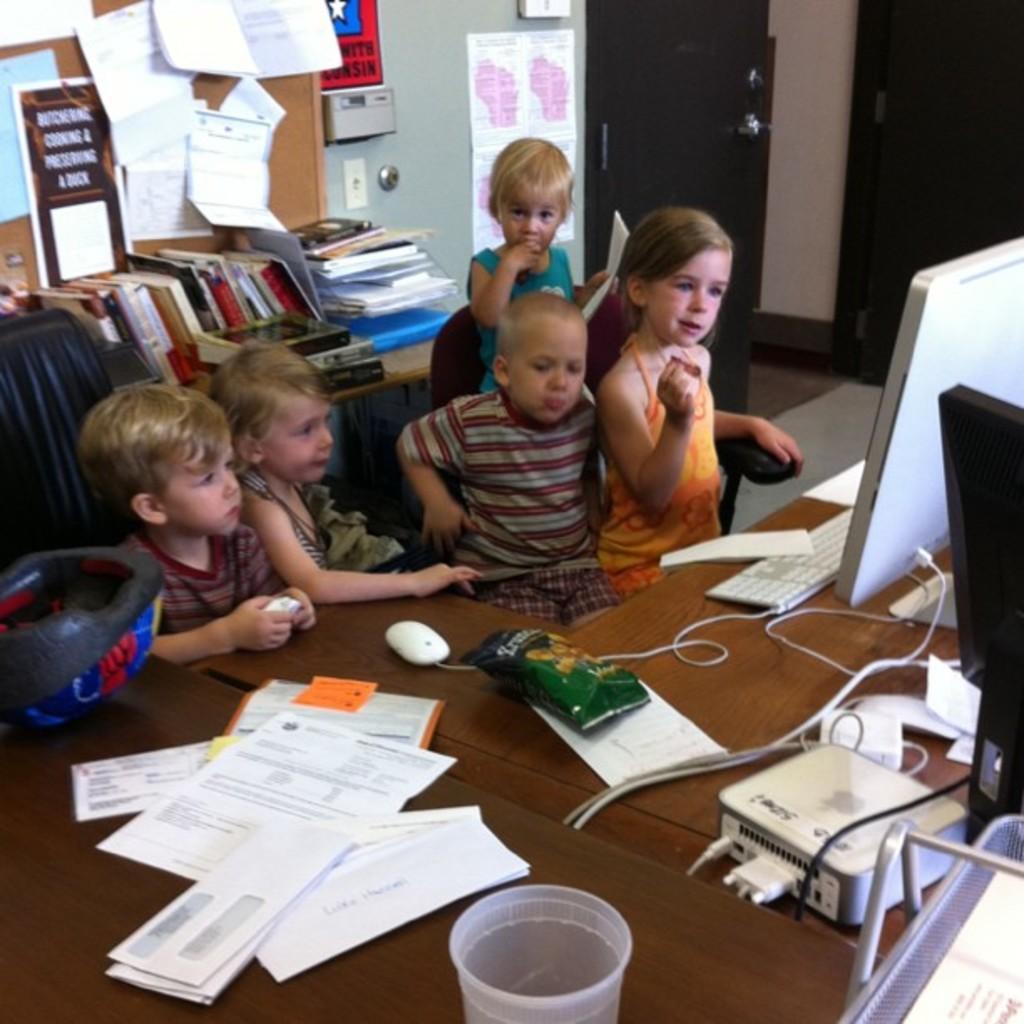Please provide a concise description of this image. In this image, there is an inside view of a room. There are some kids wearing colorful clothes. There is monitor and keyboard on the right side of the image. There is a helmet on the left side of the image. There are some books on the top left of the image. There are some papers and cup in the bottom left of the image. 